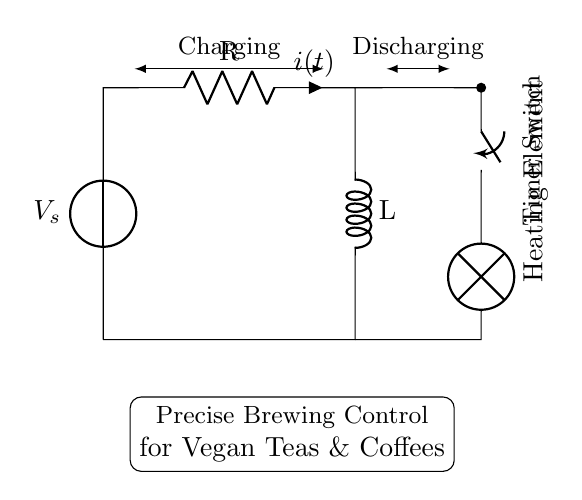What is the function of the switch in this circuit? The switch controls the flow of electricity to the heating element, allowing it to turn on or off. When open, it interrupts the circuit, and when closed, it completes the circuit for the heating element.
Answer: control flow What type of circuit is represented here? This is an RL circuit, which contains a resistor and an inductor. The resistor controls the flow of current, while the inductor stores energy in a magnetic field when current passes through it.
Answer: RL circuit What does the heating element represent in this circuit? The heating element converts electrical energy into heat to brew specialty teas and coffees, acting as the output component in the circuit.
Answer: output component What is the current flowing through the resistor indicated by? The current is indicated by the label "i(t)" next to the resistor, representing the instantaneous current at any time 't' in the circuit.
Answer: i(t) How does the timer control the brewing process? The timer switch allows for precise control over how long the heating element is on, ensuring consistent brewing times for various tea and coffee types. This is significant for maintaining quality in the beverages.
Answer: precise timing 